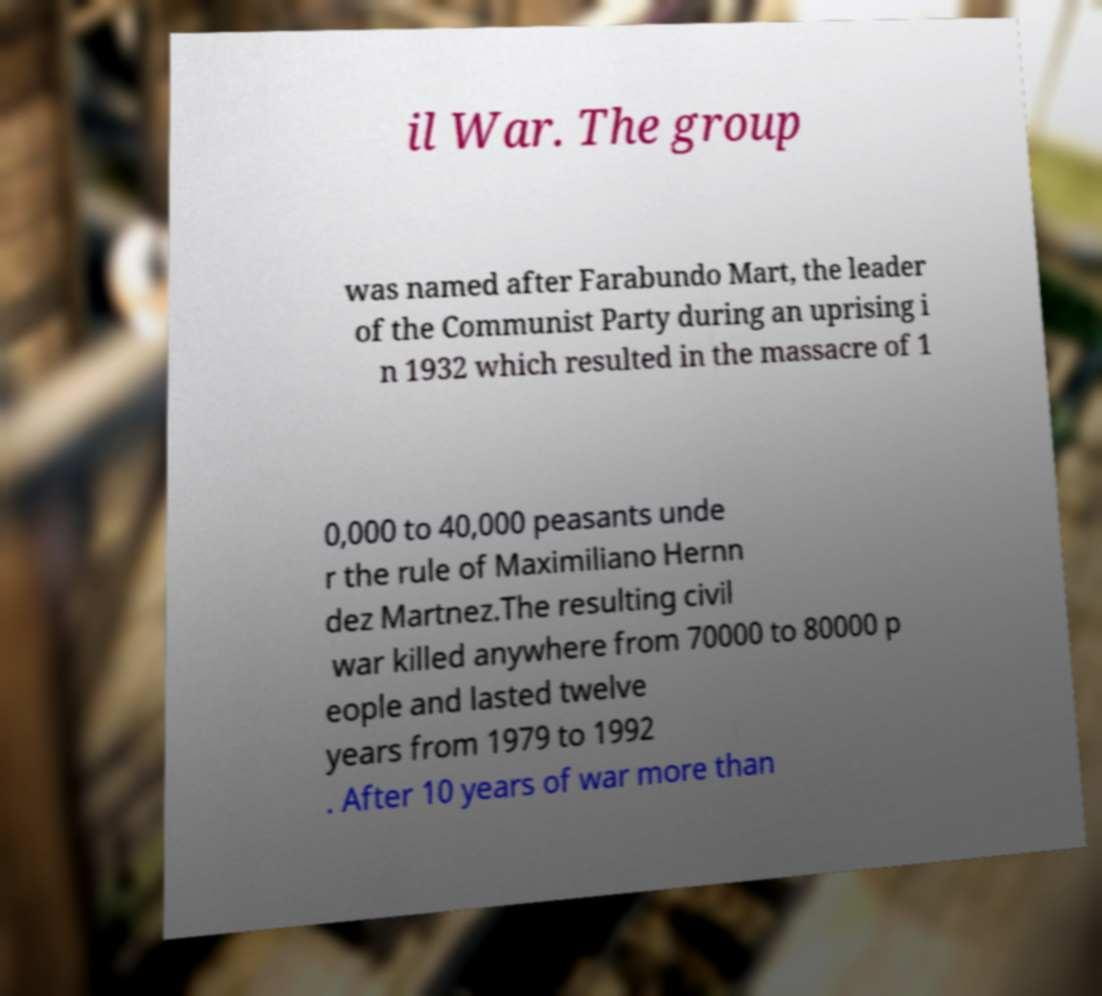Please read and relay the text visible in this image. What does it say? il War. The group was named after Farabundo Mart, the leader of the Communist Party during an uprising i n 1932 which resulted in the massacre of 1 0,000 to 40,000 peasants unde r the rule of Maximiliano Hernn dez Martnez.The resulting civil war killed anywhere from 70000 to 80000 p eople and lasted twelve years from 1979 to 1992 . After 10 years of war more than 